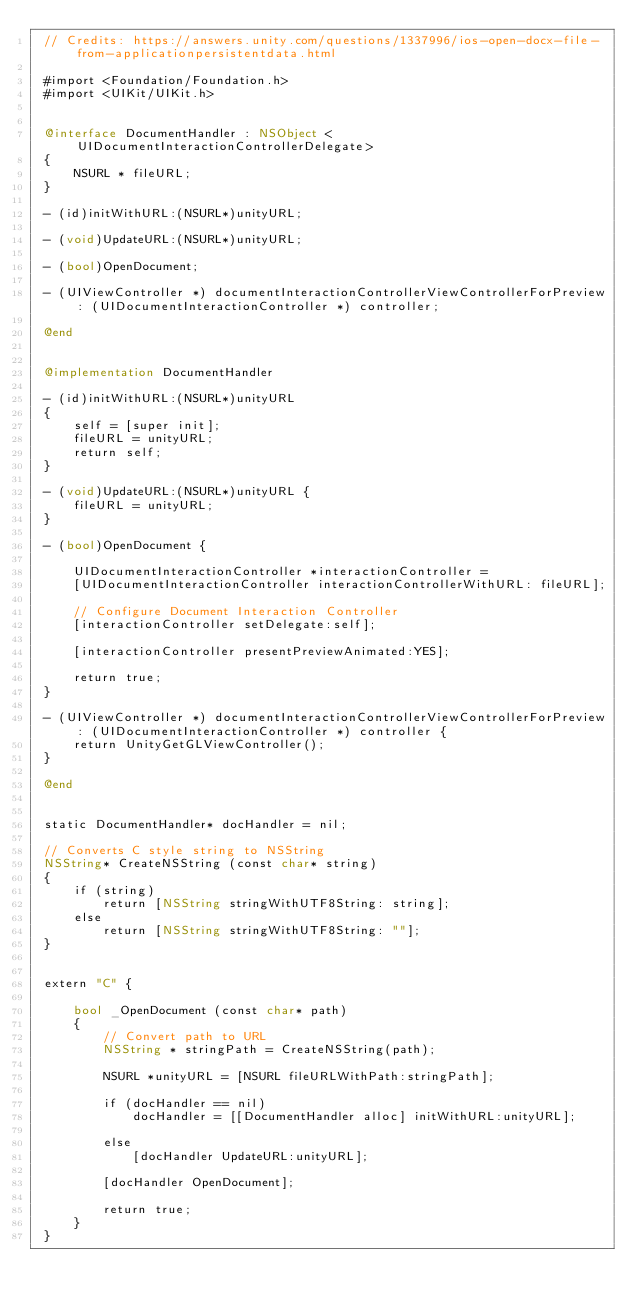Convert code to text. <code><loc_0><loc_0><loc_500><loc_500><_ObjectiveC_> // Credits: https://answers.unity.com/questions/1337996/ios-open-docx-file-from-applicationpersistentdata.html
 
 #import <Foundation/Foundation.h>
 #import <UIKit/UIKit.h>
 
 
 @interface DocumentHandler : NSObject <UIDocumentInteractionControllerDelegate>
 {
     NSURL * fileURL;
 }
 
 - (id)initWithURL:(NSURL*)unityURL;
 
 - (void)UpdateURL:(NSURL*)unityURL;
 
 - (bool)OpenDocument;
 
 - (UIViewController *) documentInteractionControllerViewControllerForPreview: (UIDocumentInteractionController *) controller;
 
 @end

 
 @implementation DocumentHandler
 
 - (id)initWithURL:(NSURL*)unityURL
 {
     self = [super init];
     fileURL = unityURL;
     return self;
 }
 
 - (void)UpdateURL:(NSURL*)unityURL {
     fileURL = unityURL;
 }
 
 - (bool)OpenDocument {
     
     UIDocumentInteractionController *interactionController =
     [UIDocumentInteractionController interactionControllerWithURL: fileURL];
     
     // Configure Document Interaction Controller
     [interactionController setDelegate:self];
     
     [interactionController presentPreviewAnimated:YES];
     
     return true;
 }
 
 - (UIViewController *) documentInteractionControllerViewControllerForPreview: (UIDocumentInteractionController *) controller {
     return UnityGetGLViewController();
 }
 
 @end
 
 
 static DocumentHandler* docHandler = nil;
 
 // Converts C style string to NSString
 NSString* CreateNSString (const char* string)
 {
     if (string)
         return [NSString stringWithUTF8String: string];
     else
         return [NSString stringWithUTF8String: ""];
 }
 
 
 extern "C" {
     
     bool _OpenDocument (const char* path)
     {
         // Convert path to URL
         NSString * stringPath = CreateNSString(path);
         
         NSURL *unityURL = [NSURL fileURLWithPath:stringPath];
         
         if (docHandler == nil)
             docHandler = [[DocumentHandler alloc] initWithURL:unityURL];
         
         else
             [docHandler UpdateURL:unityURL];
             
         [docHandler OpenDocument];
         
         return true;
     }
 }
</code> 